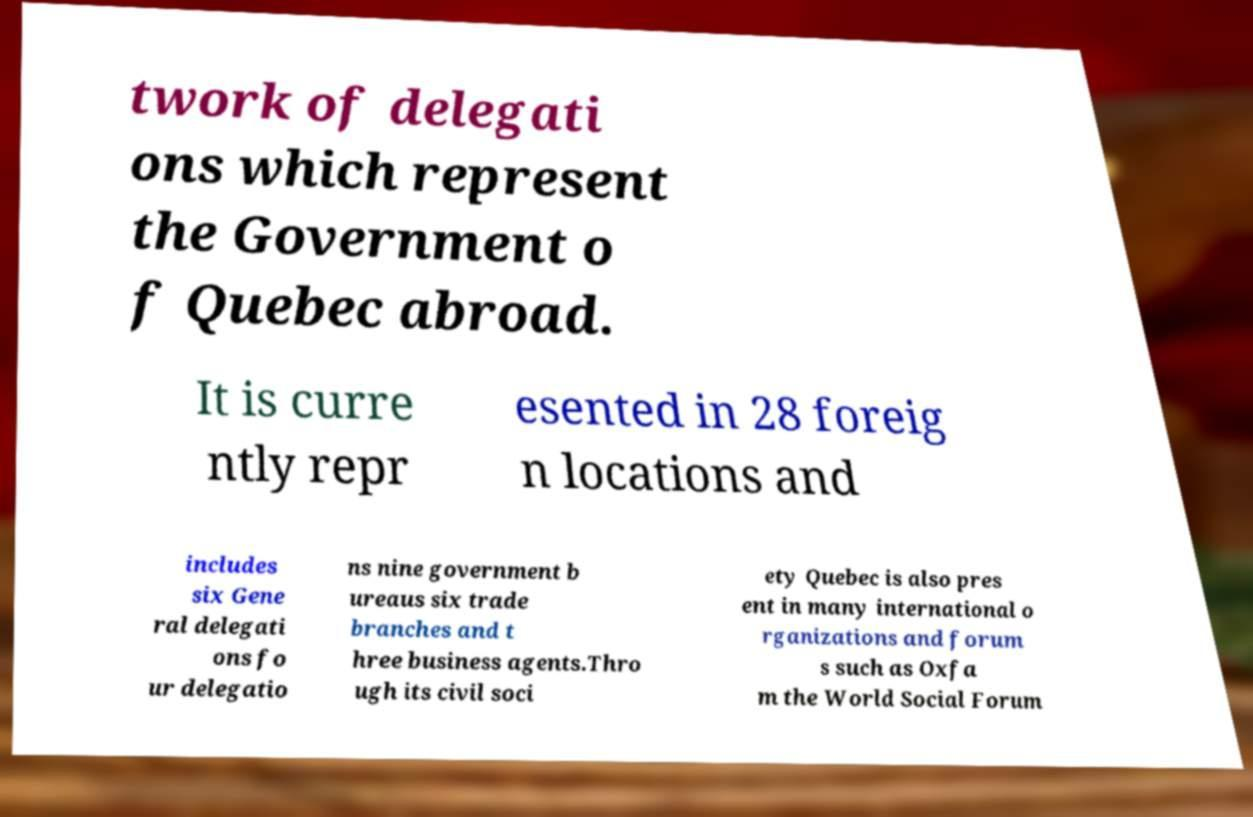Can you accurately transcribe the text from the provided image for me? twork of delegati ons which represent the Government o f Quebec abroad. It is curre ntly repr esented in 28 foreig n locations and includes six Gene ral delegati ons fo ur delegatio ns nine government b ureaus six trade branches and t hree business agents.Thro ugh its civil soci ety Quebec is also pres ent in many international o rganizations and forum s such as Oxfa m the World Social Forum 